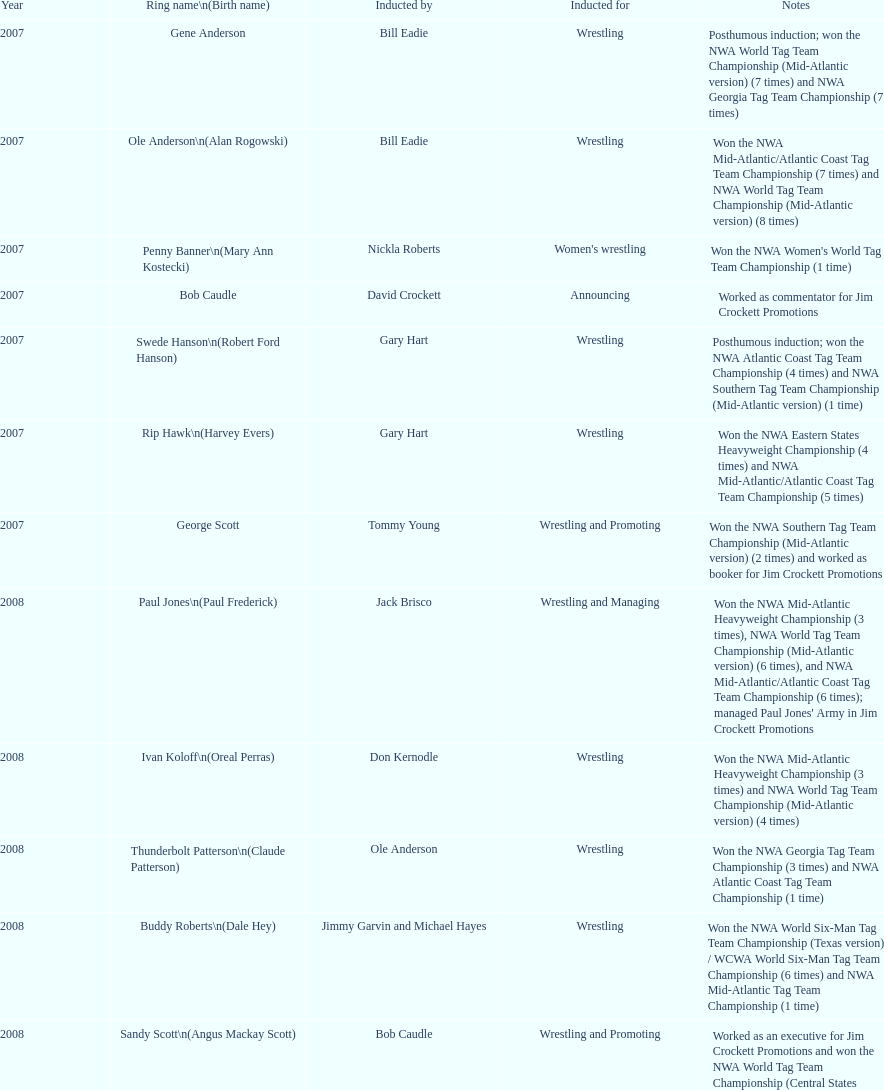Who was inducted after royal? Lance Russell. 